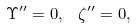Convert formula to latex. <formula><loc_0><loc_0><loc_500><loc_500>\Upsilon ^ { \prime \prime } = 0 , \text { \ } \zeta ^ { \prime \prime } = 0 ,</formula> 